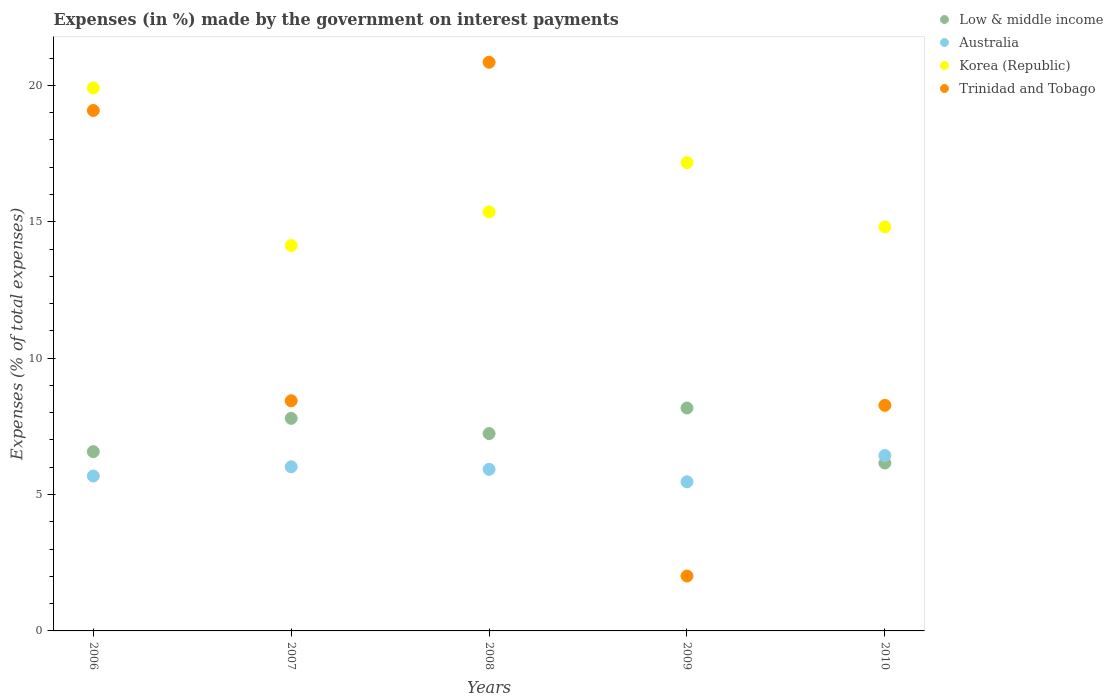How many different coloured dotlines are there?
Provide a short and direct response. 4. What is the percentage of expenses made by the government on interest payments in Low & middle income in 2007?
Your response must be concise. 7.79. Across all years, what is the maximum percentage of expenses made by the government on interest payments in Korea (Republic)?
Offer a very short reply. 19.91. Across all years, what is the minimum percentage of expenses made by the government on interest payments in Low & middle income?
Ensure brevity in your answer.  6.15. In which year was the percentage of expenses made by the government on interest payments in Korea (Republic) maximum?
Give a very brief answer. 2006. In which year was the percentage of expenses made by the government on interest payments in Trinidad and Tobago minimum?
Offer a very short reply. 2009. What is the total percentage of expenses made by the government on interest payments in Trinidad and Tobago in the graph?
Provide a succinct answer. 58.65. What is the difference between the percentage of expenses made by the government on interest payments in Australia in 2007 and that in 2008?
Offer a terse response. 0.09. What is the difference between the percentage of expenses made by the government on interest payments in Australia in 2010 and the percentage of expenses made by the government on interest payments in Korea (Republic) in 2009?
Provide a short and direct response. -10.74. What is the average percentage of expenses made by the government on interest payments in Trinidad and Tobago per year?
Give a very brief answer. 11.73. In the year 2006, what is the difference between the percentage of expenses made by the government on interest payments in Korea (Republic) and percentage of expenses made by the government on interest payments in Australia?
Keep it short and to the point. 14.23. In how many years, is the percentage of expenses made by the government on interest payments in Australia greater than 11 %?
Your response must be concise. 0. What is the ratio of the percentage of expenses made by the government on interest payments in Trinidad and Tobago in 2008 to that in 2010?
Provide a succinct answer. 2.52. Is the percentage of expenses made by the government on interest payments in Low & middle income in 2007 less than that in 2010?
Provide a succinct answer. No. What is the difference between the highest and the second highest percentage of expenses made by the government on interest payments in Australia?
Your answer should be compact. 0.41. What is the difference between the highest and the lowest percentage of expenses made by the government on interest payments in Korea (Republic)?
Your answer should be compact. 5.78. Is the sum of the percentage of expenses made by the government on interest payments in Low & middle income in 2007 and 2009 greater than the maximum percentage of expenses made by the government on interest payments in Korea (Republic) across all years?
Offer a very short reply. No. Is it the case that in every year, the sum of the percentage of expenses made by the government on interest payments in Low & middle income and percentage of expenses made by the government on interest payments in Trinidad and Tobago  is greater than the sum of percentage of expenses made by the government on interest payments in Australia and percentage of expenses made by the government on interest payments in Korea (Republic)?
Provide a succinct answer. No. Is it the case that in every year, the sum of the percentage of expenses made by the government on interest payments in Low & middle income and percentage of expenses made by the government on interest payments in Trinidad and Tobago  is greater than the percentage of expenses made by the government on interest payments in Korea (Republic)?
Your answer should be very brief. No. Is the percentage of expenses made by the government on interest payments in Low & middle income strictly greater than the percentage of expenses made by the government on interest payments in Trinidad and Tobago over the years?
Your response must be concise. No. What is the difference between two consecutive major ticks on the Y-axis?
Your response must be concise. 5. Does the graph contain grids?
Provide a succinct answer. No. What is the title of the graph?
Ensure brevity in your answer.  Expenses (in %) made by the government on interest payments. Does "Vanuatu" appear as one of the legend labels in the graph?
Provide a short and direct response. No. What is the label or title of the Y-axis?
Provide a short and direct response. Expenses (% of total expenses). What is the Expenses (% of total expenses) in Low & middle income in 2006?
Your answer should be very brief. 6.57. What is the Expenses (% of total expenses) of Australia in 2006?
Your answer should be compact. 5.68. What is the Expenses (% of total expenses) in Korea (Republic) in 2006?
Provide a short and direct response. 19.91. What is the Expenses (% of total expenses) in Trinidad and Tobago in 2006?
Give a very brief answer. 19.08. What is the Expenses (% of total expenses) in Low & middle income in 2007?
Ensure brevity in your answer.  7.79. What is the Expenses (% of total expenses) of Australia in 2007?
Make the answer very short. 6.02. What is the Expenses (% of total expenses) of Korea (Republic) in 2007?
Provide a short and direct response. 14.13. What is the Expenses (% of total expenses) in Trinidad and Tobago in 2007?
Offer a terse response. 8.44. What is the Expenses (% of total expenses) of Low & middle income in 2008?
Offer a very short reply. 7.24. What is the Expenses (% of total expenses) of Australia in 2008?
Keep it short and to the point. 5.92. What is the Expenses (% of total expenses) in Korea (Republic) in 2008?
Make the answer very short. 15.36. What is the Expenses (% of total expenses) of Trinidad and Tobago in 2008?
Keep it short and to the point. 20.85. What is the Expenses (% of total expenses) of Low & middle income in 2009?
Your answer should be very brief. 8.17. What is the Expenses (% of total expenses) in Australia in 2009?
Your response must be concise. 5.47. What is the Expenses (% of total expenses) of Korea (Republic) in 2009?
Provide a succinct answer. 17.17. What is the Expenses (% of total expenses) of Trinidad and Tobago in 2009?
Provide a short and direct response. 2.01. What is the Expenses (% of total expenses) of Low & middle income in 2010?
Make the answer very short. 6.15. What is the Expenses (% of total expenses) of Australia in 2010?
Ensure brevity in your answer.  6.43. What is the Expenses (% of total expenses) in Korea (Republic) in 2010?
Your answer should be compact. 14.81. What is the Expenses (% of total expenses) in Trinidad and Tobago in 2010?
Provide a short and direct response. 8.27. Across all years, what is the maximum Expenses (% of total expenses) of Low & middle income?
Offer a very short reply. 8.17. Across all years, what is the maximum Expenses (% of total expenses) of Australia?
Your answer should be very brief. 6.43. Across all years, what is the maximum Expenses (% of total expenses) of Korea (Republic)?
Your answer should be compact. 19.91. Across all years, what is the maximum Expenses (% of total expenses) of Trinidad and Tobago?
Ensure brevity in your answer.  20.85. Across all years, what is the minimum Expenses (% of total expenses) in Low & middle income?
Your response must be concise. 6.15. Across all years, what is the minimum Expenses (% of total expenses) in Australia?
Ensure brevity in your answer.  5.47. Across all years, what is the minimum Expenses (% of total expenses) of Korea (Republic)?
Ensure brevity in your answer.  14.13. Across all years, what is the minimum Expenses (% of total expenses) in Trinidad and Tobago?
Provide a succinct answer. 2.01. What is the total Expenses (% of total expenses) in Low & middle income in the graph?
Offer a terse response. 35.93. What is the total Expenses (% of total expenses) in Australia in the graph?
Offer a very short reply. 29.51. What is the total Expenses (% of total expenses) of Korea (Republic) in the graph?
Provide a succinct answer. 81.38. What is the total Expenses (% of total expenses) of Trinidad and Tobago in the graph?
Provide a succinct answer. 58.65. What is the difference between the Expenses (% of total expenses) in Low & middle income in 2006 and that in 2007?
Your answer should be compact. -1.22. What is the difference between the Expenses (% of total expenses) in Australia in 2006 and that in 2007?
Provide a succinct answer. -0.34. What is the difference between the Expenses (% of total expenses) in Korea (Republic) in 2006 and that in 2007?
Offer a very short reply. 5.78. What is the difference between the Expenses (% of total expenses) in Trinidad and Tobago in 2006 and that in 2007?
Make the answer very short. 10.64. What is the difference between the Expenses (% of total expenses) in Low & middle income in 2006 and that in 2008?
Make the answer very short. -0.66. What is the difference between the Expenses (% of total expenses) of Australia in 2006 and that in 2008?
Keep it short and to the point. -0.24. What is the difference between the Expenses (% of total expenses) in Korea (Republic) in 2006 and that in 2008?
Your answer should be very brief. 4.54. What is the difference between the Expenses (% of total expenses) of Trinidad and Tobago in 2006 and that in 2008?
Ensure brevity in your answer.  -1.77. What is the difference between the Expenses (% of total expenses) of Low & middle income in 2006 and that in 2009?
Provide a short and direct response. -1.6. What is the difference between the Expenses (% of total expenses) of Australia in 2006 and that in 2009?
Your answer should be very brief. 0.21. What is the difference between the Expenses (% of total expenses) of Korea (Republic) in 2006 and that in 2009?
Your answer should be very brief. 2.74. What is the difference between the Expenses (% of total expenses) in Trinidad and Tobago in 2006 and that in 2009?
Give a very brief answer. 17.07. What is the difference between the Expenses (% of total expenses) in Low & middle income in 2006 and that in 2010?
Your answer should be very brief. 0.42. What is the difference between the Expenses (% of total expenses) in Australia in 2006 and that in 2010?
Make the answer very short. -0.75. What is the difference between the Expenses (% of total expenses) in Korea (Republic) in 2006 and that in 2010?
Give a very brief answer. 5.09. What is the difference between the Expenses (% of total expenses) of Trinidad and Tobago in 2006 and that in 2010?
Provide a short and direct response. 10.81. What is the difference between the Expenses (% of total expenses) of Low & middle income in 2007 and that in 2008?
Keep it short and to the point. 0.56. What is the difference between the Expenses (% of total expenses) of Australia in 2007 and that in 2008?
Ensure brevity in your answer.  0.09. What is the difference between the Expenses (% of total expenses) of Korea (Republic) in 2007 and that in 2008?
Provide a short and direct response. -1.23. What is the difference between the Expenses (% of total expenses) of Trinidad and Tobago in 2007 and that in 2008?
Keep it short and to the point. -12.41. What is the difference between the Expenses (% of total expenses) of Low & middle income in 2007 and that in 2009?
Offer a very short reply. -0.38. What is the difference between the Expenses (% of total expenses) of Australia in 2007 and that in 2009?
Offer a very short reply. 0.55. What is the difference between the Expenses (% of total expenses) in Korea (Republic) in 2007 and that in 2009?
Your answer should be very brief. -3.04. What is the difference between the Expenses (% of total expenses) of Trinidad and Tobago in 2007 and that in 2009?
Give a very brief answer. 6.43. What is the difference between the Expenses (% of total expenses) in Low & middle income in 2007 and that in 2010?
Keep it short and to the point. 1.64. What is the difference between the Expenses (% of total expenses) of Australia in 2007 and that in 2010?
Your response must be concise. -0.41. What is the difference between the Expenses (% of total expenses) of Korea (Republic) in 2007 and that in 2010?
Provide a short and direct response. -0.68. What is the difference between the Expenses (% of total expenses) of Trinidad and Tobago in 2007 and that in 2010?
Offer a very short reply. 0.17. What is the difference between the Expenses (% of total expenses) in Low & middle income in 2008 and that in 2009?
Your answer should be compact. -0.94. What is the difference between the Expenses (% of total expenses) in Australia in 2008 and that in 2009?
Keep it short and to the point. 0.46. What is the difference between the Expenses (% of total expenses) in Korea (Republic) in 2008 and that in 2009?
Provide a succinct answer. -1.81. What is the difference between the Expenses (% of total expenses) in Trinidad and Tobago in 2008 and that in 2009?
Make the answer very short. 18.84. What is the difference between the Expenses (% of total expenses) in Low & middle income in 2008 and that in 2010?
Provide a short and direct response. 1.08. What is the difference between the Expenses (% of total expenses) of Australia in 2008 and that in 2010?
Your answer should be compact. -0.51. What is the difference between the Expenses (% of total expenses) of Korea (Republic) in 2008 and that in 2010?
Your answer should be compact. 0.55. What is the difference between the Expenses (% of total expenses) of Trinidad and Tobago in 2008 and that in 2010?
Offer a terse response. 12.58. What is the difference between the Expenses (% of total expenses) in Low & middle income in 2009 and that in 2010?
Your answer should be very brief. 2.02. What is the difference between the Expenses (% of total expenses) of Australia in 2009 and that in 2010?
Offer a very short reply. -0.96. What is the difference between the Expenses (% of total expenses) in Korea (Republic) in 2009 and that in 2010?
Keep it short and to the point. 2.36. What is the difference between the Expenses (% of total expenses) in Trinidad and Tobago in 2009 and that in 2010?
Provide a short and direct response. -6.26. What is the difference between the Expenses (% of total expenses) in Low & middle income in 2006 and the Expenses (% of total expenses) in Australia in 2007?
Ensure brevity in your answer.  0.56. What is the difference between the Expenses (% of total expenses) of Low & middle income in 2006 and the Expenses (% of total expenses) of Korea (Republic) in 2007?
Ensure brevity in your answer.  -7.56. What is the difference between the Expenses (% of total expenses) in Low & middle income in 2006 and the Expenses (% of total expenses) in Trinidad and Tobago in 2007?
Offer a very short reply. -1.87. What is the difference between the Expenses (% of total expenses) of Australia in 2006 and the Expenses (% of total expenses) of Korea (Republic) in 2007?
Your response must be concise. -8.45. What is the difference between the Expenses (% of total expenses) in Australia in 2006 and the Expenses (% of total expenses) in Trinidad and Tobago in 2007?
Offer a very short reply. -2.76. What is the difference between the Expenses (% of total expenses) of Korea (Republic) in 2006 and the Expenses (% of total expenses) of Trinidad and Tobago in 2007?
Your answer should be compact. 11.47. What is the difference between the Expenses (% of total expenses) of Low & middle income in 2006 and the Expenses (% of total expenses) of Australia in 2008?
Your answer should be compact. 0.65. What is the difference between the Expenses (% of total expenses) in Low & middle income in 2006 and the Expenses (% of total expenses) in Korea (Republic) in 2008?
Offer a terse response. -8.79. What is the difference between the Expenses (% of total expenses) of Low & middle income in 2006 and the Expenses (% of total expenses) of Trinidad and Tobago in 2008?
Provide a short and direct response. -14.27. What is the difference between the Expenses (% of total expenses) in Australia in 2006 and the Expenses (% of total expenses) in Korea (Republic) in 2008?
Provide a succinct answer. -9.68. What is the difference between the Expenses (% of total expenses) in Australia in 2006 and the Expenses (% of total expenses) in Trinidad and Tobago in 2008?
Your answer should be compact. -15.17. What is the difference between the Expenses (% of total expenses) of Korea (Republic) in 2006 and the Expenses (% of total expenses) of Trinidad and Tobago in 2008?
Provide a short and direct response. -0.94. What is the difference between the Expenses (% of total expenses) in Low & middle income in 2006 and the Expenses (% of total expenses) in Australia in 2009?
Give a very brief answer. 1.11. What is the difference between the Expenses (% of total expenses) in Low & middle income in 2006 and the Expenses (% of total expenses) in Korea (Republic) in 2009?
Your answer should be very brief. -10.6. What is the difference between the Expenses (% of total expenses) of Low & middle income in 2006 and the Expenses (% of total expenses) of Trinidad and Tobago in 2009?
Make the answer very short. 4.56. What is the difference between the Expenses (% of total expenses) in Australia in 2006 and the Expenses (% of total expenses) in Korea (Republic) in 2009?
Your response must be concise. -11.49. What is the difference between the Expenses (% of total expenses) in Australia in 2006 and the Expenses (% of total expenses) in Trinidad and Tobago in 2009?
Your answer should be compact. 3.67. What is the difference between the Expenses (% of total expenses) in Korea (Republic) in 2006 and the Expenses (% of total expenses) in Trinidad and Tobago in 2009?
Make the answer very short. 17.89. What is the difference between the Expenses (% of total expenses) of Low & middle income in 2006 and the Expenses (% of total expenses) of Australia in 2010?
Ensure brevity in your answer.  0.14. What is the difference between the Expenses (% of total expenses) in Low & middle income in 2006 and the Expenses (% of total expenses) in Korea (Republic) in 2010?
Make the answer very short. -8.24. What is the difference between the Expenses (% of total expenses) of Low & middle income in 2006 and the Expenses (% of total expenses) of Trinidad and Tobago in 2010?
Offer a very short reply. -1.7. What is the difference between the Expenses (% of total expenses) of Australia in 2006 and the Expenses (% of total expenses) of Korea (Republic) in 2010?
Keep it short and to the point. -9.13. What is the difference between the Expenses (% of total expenses) of Australia in 2006 and the Expenses (% of total expenses) of Trinidad and Tobago in 2010?
Ensure brevity in your answer.  -2.59. What is the difference between the Expenses (% of total expenses) in Korea (Republic) in 2006 and the Expenses (% of total expenses) in Trinidad and Tobago in 2010?
Give a very brief answer. 11.64. What is the difference between the Expenses (% of total expenses) of Low & middle income in 2007 and the Expenses (% of total expenses) of Australia in 2008?
Make the answer very short. 1.87. What is the difference between the Expenses (% of total expenses) of Low & middle income in 2007 and the Expenses (% of total expenses) of Korea (Republic) in 2008?
Keep it short and to the point. -7.57. What is the difference between the Expenses (% of total expenses) in Low & middle income in 2007 and the Expenses (% of total expenses) in Trinidad and Tobago in 2008?
Provide a succinct answer. -13.05. What is the difference between the Expenses (% of total expenses) in Australia in 2007 and the Expenses (% of total expenses) in Korea (Republic) in 2008?
Your answer should be compact. -9.35. What is the difference between the Expenses (% of total expenses) of Australia in 2007 and the Expenses (% of total expenses) of Trinidad and Tobago in 2008?
Your response must be concise. -14.83. What is the difference between the Expenses (% of total expenses) of Korea (Republic) in 2007 and the Expenses (% of total expenses) of Trinidad and Tobago in 2008?
Offer a terse response. -6.72. What is the difference between the Expenses (% of total expenses) in Low & middle income in 2007 and the Expenses (% of total expenses) in Australia in 2009?
Provide a short and direct response. 2.33. What is the difference between the Expenses (% of total expenses) in Low & middle income in 2007 and the Expenses (% of total expenses) in Korea (Republic) in 2009?
Provide a succinct answer. -9.38. What is the difference between the Expenses (% of total expenses) in Low & middle income in 2007 and the Expenses (% of total expenses) in Trinidad and Tobago in 2009?
Give a very brief answer. 5.78. What is the difference between the Expenses (% of total expenses) in Australia in 2007 and the Expenses (% of total expenses) in Korea (Republic) in 2009?
Your answer should be compact. -11.15. What is the difference between the Expenses (% of total expenses) in Australia in 2007 and the Expenses (% of total expenses) in Trinidad and Tobago in 2009?
Your answer should be very brief. 4. What is the difference between the Expenses (% of total expenses) in Korea (Republic) in 2007 and the Expenses (% of total expenses) in Trinidad and Tobago in 2009?
Keep it short and to the point. 12.12. What is the difference between the Expenses (% of total expenses) of Low & middle income in 2007 and the Expenses (% of total expenses) of Australia in 2010?
Offer a terse response. 1.36. What is the difference between the Expenses (% of total expenses) of Low & middle income in 2007 and the Expenses (% of total expenses) of Korea (Republic) in 2010?
Your answer should be very brief. -7.02. What is the difference between the Expenses (% of total expenses) in Low & middle income in 2007 and the Expenses (% of total expenses) in Trinidad and Tobago in 2010?
Offer a terse response. -0.48. What is the difference between the Expenses (% of total expenses) in Australia in 2007 and the Expenses (% of total expenses) in Korea (Republic) in 2010?
Your response must be concise. -8.79. What is the difference between the Expenses (% of total expenses) in Australia in 2007 and the Expenses (% of total expenses) in Trinidad and Tobago in 2010?
Your answer should be compact. -2.25. What is the difference between the Expenses (% of total expenses) of Korea (Republic) in 2007 and the Expenses (% of total expenses) of Trinidad and Tobago in 2010?
Offer a very short reply. 5.86. What is the difference between the Expenses (% of total expenses) of Low & middle income in 2008 and the Expenses (% of total expenses) of Australia in 2009?
Make the answer very short. 1.77. What is the difference between the Expenses (% of total expenses) of Low & middle income in 2008 and the Expenses (% of total expenses) of Korea (Republic) in 2009?
Provide a short and direct response. -9.93. What is the difference between the Expenses (% of total expenses) in Low & middle income in 2008 and the Expenses (% of total expenses) in Trinidad and Tobago in 2009?
Keep it short and to the point. 5.22. What is the difference between the Expenses (% of total expenses) in Australia in 2008 and the Expenses (% of total expenses) in Korea (Republic) in 2009?
Your response must be concise. -11.25. What is the difference between the Expenses (% of total expenses) of Australia in 2008 and the Expenses (% of total expenses) of Trinidad and Tobago in 2009?
Give a very brief answer. 3.91. What is the difference between the Expenses (% of total expenses) of Korea (Republic) in 2008 and the Expenses (% of total expenses) of Trinidad and Tobago in 2009?
Your response must be concise. 13.35. What is the difference between the Expenses (% of total expenses) in Low & middle income in 2008 and the Expenses (% of total expenses) in Australia in 2010?
Give a very brief answer. 0.81. What is the difference between the Expenses (% of total expenses) in Low & middle income in 2008 and the Expenses (% of total expenses) in Korea (Republic) in 2010?
Provide a short and direct response. -7.58. What is the difference between the Expenses (% of total expenses) of Low & middle income in 2008 and the Expenses (% of total expenses) of Trinidad and Tobago in 2010?
Offer a very short reply. -1.03. What is the difference between the Expenses (% of total expenses) of Australia in 2008 and the Expenses (% of total expenses) of Korea (Republic) in 2010?
Your answer should be compact. -8.89. What is the difference between the Expenses (% of total expenses) in Australia in 2008 and the Expenses (% of total expenses) in Trinidad and Tobago in 2010?
Your answer should be compact. -2.35. What is the difference between the Expenses (% of total expenses) of Korea (Republic) in 2008 and the Expenses (% of total expenses) of Trinidad and Tobago in 2010?
Make the answer very short. 7.09. What is the difference between the Expenses (% of total expenses) in Low & middle income in 2009 and the Expenses (% of total expenses) in Australia in 2010?
Give a very brief answer. 1.74. What is the difference between the Expenses (% of total expenses) in Low & middle income in 2009 and the Expenses (% of total expenses) in Korea (Republic) in 2010?
Offer a very short reply. -6.64. What is the difference between the Expenses (% of total expenses) of Low & middle income in 2009 and the Expenses (% of total expenses) of Trinidad and Tobago in 2010?
Make the answer very short. -0.1. What is the difference between the Expenses (% of total expenses) in Australia in 2009 and the Expenses (% of total expenses) in Korea (Republic) in 2010?
Give a very brief answer. -9.35. What is the difference between the Expenses (% of total expenses) in Australia in 2009 and the Expenses (% of total expenses) in Trinidad and Tobago in 2010?
Your answer should be very brief. -2.8. What is the difference between the Expenses (% of total expenses) in Korea (Republic) in 2009 and the Expenses (% of total expenses) in Trinidad and Tobago in 2010?
Give a very brief answer. 8.9. What is the average Expenses (% of total expenses) in Low & middle income per year?
Give a very brief answer. 7.19. What is the average Expenses (% of total expenses) of Australia per year?
Give a very brief answer. 5.9. What is the average Expenses (% of total expenses) of Korea (Republic) per year?
Offer a terse response. 16.28. What is the average Expenses (% of total expenses) in Trinidad and Tobago per year?
Make the answer very short. 11.73. In the year 2006, what is the difference between the Expenses (% of total expenses) in Low & middle income and Expenses (% of total expenses) in Australia?
Provide a succinct answer. 0.89. In the year 2006, what is the difference between the Expenses (% of total expenses) in Low & middle income and Expenses (% of total expenses) in Korea (Republic)?
Your answer should be compact. -13.33. In the year 2006, what is the difference between the Expenses (% of total expenses) in Low & middle income and Expenses (% of total expenses) in Trinidad and Tobago?
Offer a very short reply. -12.51. In the year 2006, what is the difference between the Expenses (% of total expenses) in Australia and Expenses (% of total expenses) in Korea (Republic)?
Give a very brief answer. -14.23. In the year 2006, what is the difference between the Expenses (% of total expenses) of Australia and Expenses (% of total expenses) of Trinidad and Tobago?
Provide a short and direct response. -13.4. In the year 2006, what is the difference between the Expenses (% of total expenses) in Korea (Republic) and Expenses (% of total expenses) in Trinidad and Tobago?
Your response must be concise. 0.83. In the year 2007, what is the difference between the Expenses (% of total expenses) of Low & middle income and Expenses (% of total expenses) of Australia?
Your answer should be very brief. 1.78. In the year 2007, what is the difference between the Expenses (% of total expenses) of Low & middle income and Expenses (% of total expenses) of Korea (Republic)?
Offer a terse response. -6.34. In the year 2007, what is the difference between the Expenses (% of total expenses) of Low & middle income and Expenses (% of total expenses) of Trinidad and Tobago?
Make the answer very short. -0.65. In the year 2007, what is the difference between the Expenses (% of total expenses) in Australia and Expenses (% of total expenses) in Korea (Republic)?
Make the answer very short. -8.11. In the year 2007, what is the difference between the Expenses (% of total expenses) in Australia and Expenses (% of total expenses) in Trinidad and Tobago?
Ensure brevity in your answer.  -2.42. In the year 2007, what is the difference between the Expenses (% of total expenses) in Korea (Republic) and Expenses (% of total expenses) in Trinidad and Tobago?
Your answer should be compact. 5.69. In the year 2008, what is the difference between the Expenses (% of total expenses) of Low & middle income and Expenses (% of total expenses) of Australia?
Ensure brevity in your answer.  1.31. In the year 2008, what is the difference between the Expenses (% of total expenses) in Low & middle income and Expenses (% of total expenses) in Korea (Republic)?
Your response must be concise. -8.13. In the year 2008, what is the difference between the Expenses (% of total expenses) of Low & middle income and Expenses (% of total expenses) of Trinidad and Tobago?
Your answer should be compact. -13.61. In the year 2008, what is the difference between the Expenses (% of total expenses) of Australia and Expenses (% of total expenses) of Korea (Republic)?
Ensure brevity in your answer.  -9.44. In the year 2008, what is the difference between the Expenses (% of total expenses) of Australia and Expenses (% of total expenses) of Trinidad and Tobago?
Give a very brief answer. -14.92. In the year 2008, what is the difference between the Expenses (% of total expenses) in Korea (Republic) and Expenses (% of total expenses) in Trinidad and Tobago?
Keep it short and to the point. -5.49. In the year 2009, what is the difference between the Expenses (% of total expenses) in Low & middle income and Expenses (% of total expenses) in Australia?
Give a very brief answer. 2.71. In the year 2009, what is the difference between the Expenses (% of total expenses) of Low & middle income and Expenses (% of total expenses) of Korea (Republic)?
Provide a succinct answer. -9. In the year 2009, what is the difference between the Expenses (% of total expenses) of Low & middle income and Expenses (% of total expenses) of Trinidad and Tobago?
Give a very brief answer. 6.16. In the year 2009, what is the difference between the Expenses (% of total expenses) in Australia and Expenses (% of total expenses) in Korea (Republic)?
Provide a succinct answer. -11.7. In the year 2009, what is the difference between the Expenses (% of total expenses) of Australia and Expenses (% of total expenses) of Trinidad and Tobago?
Your response must be concise. 3.45. In the year 2009, what is the difference between the Expenses (% of total expenses) of Korea (Republic) and Expenses (% of total expenses) of Trinidad and Tobago?
Provide a succinct answer. 15.16. In the year 2010, what is the difference between the Expenses (% of total expenses) in Low & middle income and Expenses (% of total expenses) in Australia?
Ensure brevity in your answer.  -0.28. In the year 2010, what is the difference between the Expenses (% of total expenses) in Low & middle income and Expenses (% of total expenses) in Korea (Republic)?
Offer a very short reply. -8.66. In the year 2010, what is the difference between the Expenses (% of total expenses) of Low & middle income and Expenses (% of total expenses) of Trinidad and Tobago?
Your response must be concise. -2.12. In the year 2010, what is the difference between the Expenses (% of total expenses) in Australia and Expenses (% of total expenses) in Korea (Republic)?
Your answer should be compact. -8.38. In the year 2010, what is the difference between the Expenses (% of total expenses) in Australia and Expenses (% of total expenses) in Trinidad and Tobago?
Your answer should be compact. -1.84. In the year 2010, what is the difference between the Expenses (% of total expenses) of Korea (Republic) and Expenses (% of total expenses) of Trinidad and Tobago?
Offer a very short reply. 6.54. What is the ratio of the Expenses (% of total expenses) in Low & middle income in 2006 to that in 2007?
Offer a terse response. 0.84. What is the ratio of the Expenses (% of total expenses) of Australia in 2006 to that in 2007?
Your answer should be compact. 0.94. What is the ratio of the Expenses (% of total expenses) of Korea (Republic) in 2006 to that in 2007?
Your response must be concise. 1.41. What is the ratio of the Expenses (% of total expenses) of Trinidad and Tobago in 2006 to that in 2007?
Offer a terse response. 2.26. What is the ratio of the Expenses (% of total expenses) of Low & middle income in 2006 to that in 2008?
Offer a very short reply. 0.91. What is the ratio of the Expenses (% of total expenses) in Australia in 2006 to that in 2008?
Your response must be concise. 0.96. What is the ratio of the Expenses (% of total expenses) of Korea (Republic) in 2006 to that in 2008?
Keep it short and to the point. 1.3. What is the ratio of the Expenses (% of total expenses) in Trinidad and Tobago in 2006 to that in 2008?
Keep it short and to the point. 0.92. What is the ratio of the Expenses (% of total expenses) in Low & middle income in 2006 to that in 2009?
Ensure brevity in your answer.  0.8. What is the ratio of the Expenses (% of total expenses) in Australia in 2006 to that in 2009?
Offer a terse response. 1.04. What is the ratio of the Expenses (% of total expenses) of Korea (Republic) in 2006 to that in 2009?
Offer a terse response. 1.16. What is the ratio of the Expenses (% of total expenses) in Trinidad and Tobago in 2006 to that in 2009?
Offer a terse response. 9.48. What is the ratio of the Expenses (% of total expenses) of Low & middle income in 2006 to that in 2010?
Keep it short and to the point. 1.07. What is the ratio of the Expenses (% of total expenses) of Australia in 2006 to that in 2010?
Your answer should be very brief. 0.88. What is the ratio of the Expenses (% of total expenses) in Korea (Republic) in 2006 to that in 2010?
Offer a very short reply. 1.34. What is the ratio of the Expenses (% of total expenses) of Trinidad and Tobago in 2006 to that in 2010?
Provide a succinct answer. 2.31. What is the ratio of the Expenses (% of total expenses) in Low & middle income in 2007 to that in 2008?
Offer a very short reply. 1.08. What is the ratio of the Expenses (% of total expenses) in Australia in 2007 to that in 2008?
Offer a very short reply. 1.02. What is the ratio of the Expenses (% of total expenses) of Korea (Republic) in 2007 to that in 2008?
Offer a very short reply. 0.92. What is the ratio of the Expenses (% of total expenses) of Trinidad and Tobago in 2007 to that in 2008?
Ensure brevity in your answer.  0.4. What is the ratio of the Expenses (% of total expenses) in Low & middle income in 2007 to that in 2009?
Provide a short and direct response. 0.95. What is the ratio of the Expenses (% of total expenses) of Australia in 2007 to that in 2009?
Your answer should be very brief. 1.1. What is the ratio of the Expenses (% of total expenses) of Korea (Republic) in 2007 to that in 2009?
Keep it short and to the point. 0.82. What is the ratio of the Expenses (% of total expenses) of Trinidad and Tobago in 2007 to that in 2009?
Your answer should be compact. 4.19. What is the ratio of the Expenses (% of total expenses) in Low & middle income in 2007 to that in 2010?
Provide a short and direct response. 1.27. What is the ratio of the Expenses (% of total expenses) of Australia in 2007 to that in 2010?
Provide a succinct answer. 0.94. What is the ratio of the Expenses (% of total expenses) of Korea (Republic) in 2007 to that in 2010?
Offer a terse response. 0.95. What is the ratio of the Expenses (% of total expenses) of Trinidad and Tobago in 2007 to that in 2010?
Your response must be concise. 1.02. What is the ratio of the Expenses (% of total expenses) of Low & middle income in 2008 to that in 2009?
Ensure brevity in your answer.  0.89. What is the ratio of the Expenses (% of total expenses) of Australia in 2008 to that in 2009?
Ensure brevity in your answer.  1.08. What is the ratio of the Expenses (% of total expenses) in Korea (Republic) in 2008 to that in 2009?
Provide a succinct answer. 0.89. What is the ratio of the Expenses (% of total expenses) in Trinidad and Tobago in 2008 to that in 2009?
Make the answer very short. 10.36. What is the ratio of the Expenses (% of total expenses) in Low & middle income in 2008 to that in 2010?
Provide a succinct answer. 1.18. What is the ratio of the Expenses (% of total expenses) of Australia in 2008 to that in 2010?
Make the answer very short. 0.92. What is the ratio of the Expenses (% of total expenses) of Korea (Republic) in 2008 to that in 2010?
Offer a terse response. 1.04. What is the ratio of the Expenses (% of total expenses) in Trinidad and Tobago in 2008 to that in 2010?
Your response must be concise. 2.52. What is the ratio of the Expenses (% of total expenses) in Low & middle income in 2009 to that in 2010?
Provide a succinct answer. 1.33. What is the ratio of the Expenses (% of total expenses) in Australia in 2009 to that in 2010?
Make the answer very short. 0.85. What is the ratio of the Expenses (% of total expenses) in Korea (Republic) in 2009 to that in 2010?
Your answer should be compact. 1.16. What is the ratio of the Expenses (% of total expenses) of Trinidad and Tobago in 2009 to that in 2010?
Give a very brief answer. 0.24. What is the difference between the highest and the second highest Expenses (% of total expenses) of Low & middle income?
Ensure brevity in your answer.  0.38. What is the difference between the highest and the second highest Expenses (% of total expenses) of Australia?
Offer a very short reply. 0.41. What is the difference between the highest and the second highest Expenses (% of total expenses) of Korea (Republic)?
Provide a short and direct response. 2.74. What is the difference between the highest and the second highest Expenses (% of total expenses) in Trinidad and Tobago?
Make the answer very short. 1.77. What is the difference between the highest and the lowest Expenses (% of total expenses) in Low & middle income?
Ensure brevity in your answer.  2.02. What is the difference between the highest and the lowest Expenses (% of total expenses) of Australia?
Your response must be concise. 0.96. What is the difference between the highest and the lowest Expenses (% of total expenses) of Korea (Republic)?
Provide a succinct answer. 5.78. What is the difference between the highest and the lowest Expenses (% of total expenses) in Trinidad and Tobago?
Give a very brief answer. 18.84. 